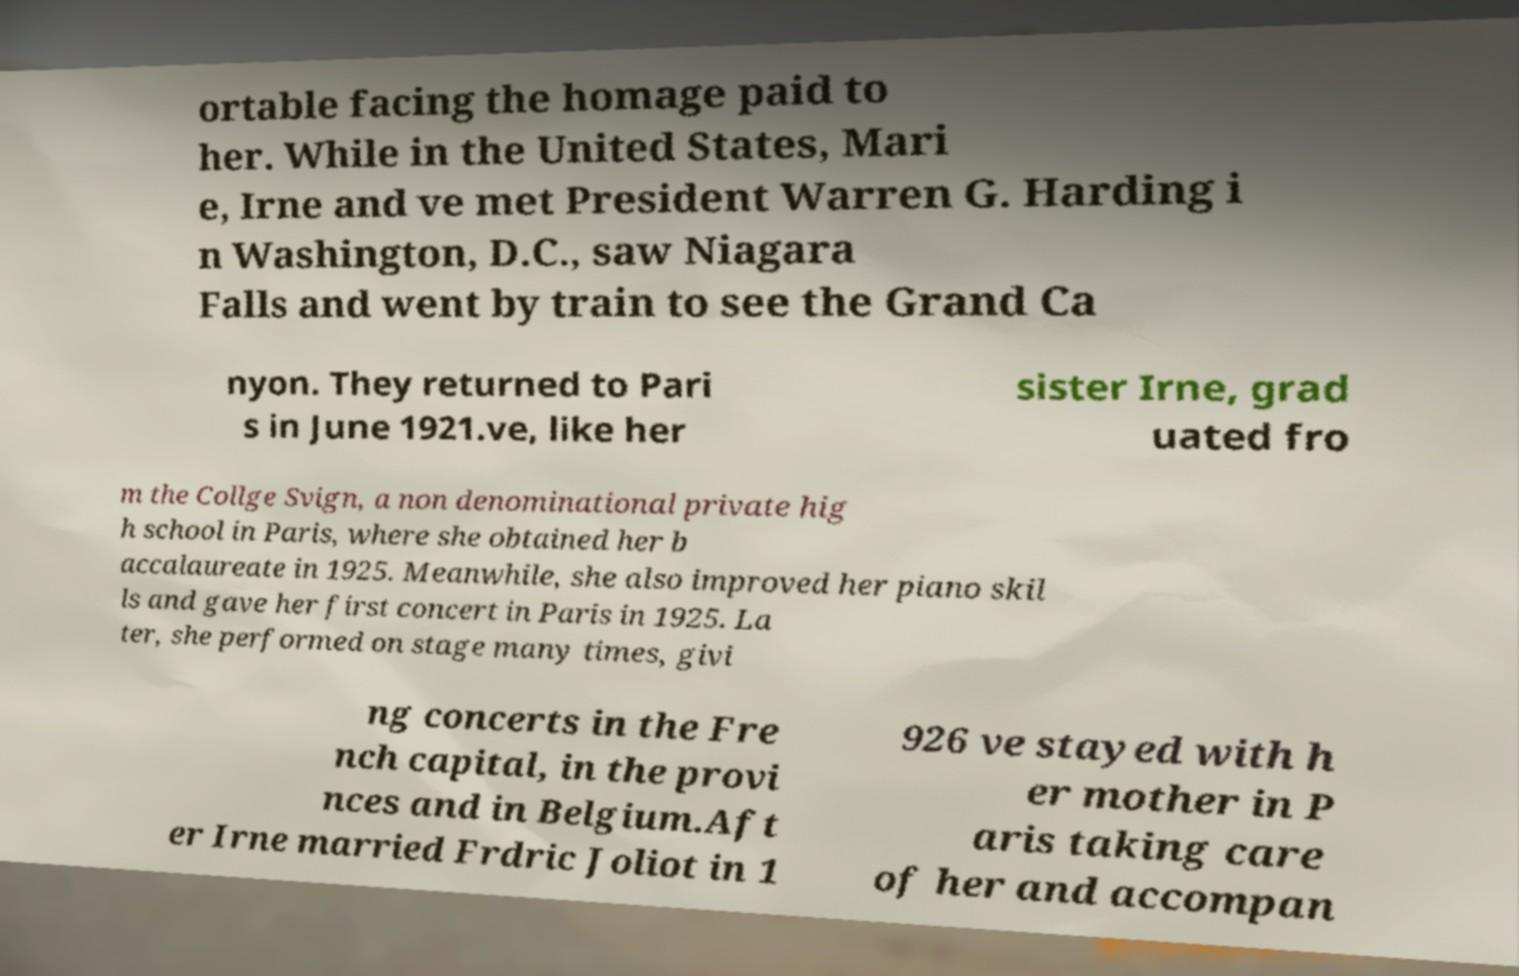Could you assist in decoding the text presented in this image and type it out clearly? ortable facing the homage paid to her. While in the United States, Mari e, Irne and ve met President Warren G. Harding i n Washington, D.C., saw Niagara Falls and went by train to see the Grand Ca nyon. They returned to Pari s in June 1921.ve, like her sister Irne, grad uated fro m the Collge Svign, a non denominational private hig h school in Paris, where she obtained her b accalaureate in 1925. Meanwhile, she also improved her piano skil ls and gave her first concert in Paris in 1925. La ter, she performed on stage many times, givi ng concerts in the Fre nch capital, in the provi nces and in Belgium.Aft er Irne married Frdric Joliot in 1 926 ve stayed with h er mother in P aris taking care of her and accompan 